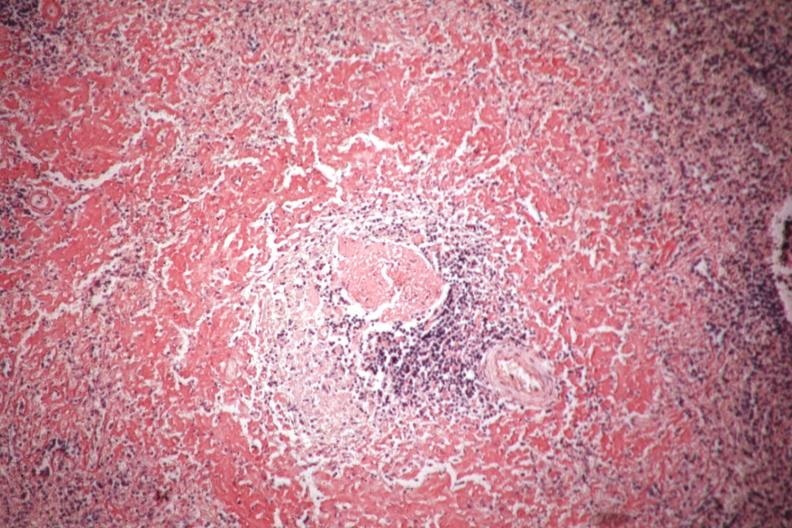s chromophobe adenoma present?
Answer the question using a single word or phrase. No 